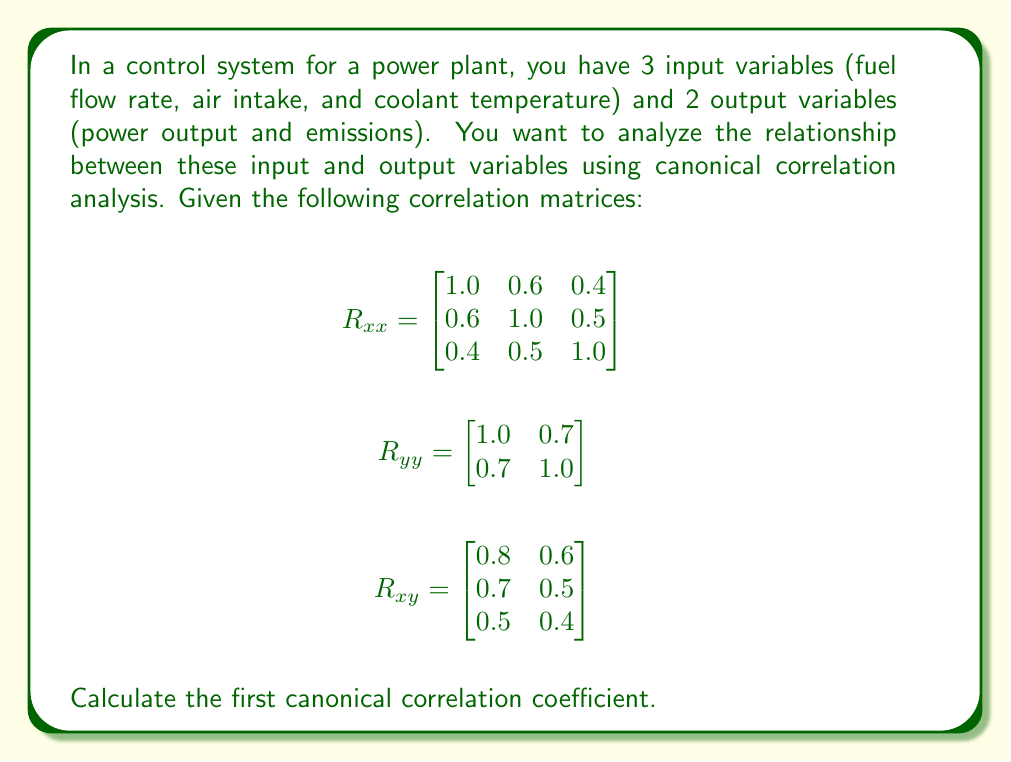Provide a solution to this math problem. To find the first canonical correlation coefficient, we need to follow these steps:

1. Calculate $R_{xx}^{-1}$ and $R_{yy}^{-1}$

First, let's calculate $R_{xx}^{-1}$:

$$R_{xx}^{-1} = \begin{bmatrix}
1.5625 & -0.9375 & -0.1875 \\
-0.9375 & 1.5625 & -0.4375 \\
-0.1875 & -0.4375 & 1.1875
\end{bmatrix}$$

Now, $R_{yy}^{-1}$:

$$R_{yy}^{-1} = \begin{bmatrix}
1.9608 & -1.3725 \\
-1.3725 & 1.9608
\end{bmatrix}$$

2. Calculate $R_{xx}^{-1}R_{xy}R_{yy}^{-1}R_{yx}$

$$R_{xx}^{-1}R_{xy}R_{yy}^{-1}R_{yx} = \begin{bmatrix}
0.7656 & -0.4688 & -0.0938 \\
-0.4688 & 0.5781 & -0.1406 \\
-0.0938 & -0.1406 & 0.2656
\end{bmatrix}$$

3. Find the eigenvalues of this matrix

The characteristic equation is:

$$(0.7656 - \lambda)(0.5781 - \lambda)(0.2656 - \lambda) + (-0.4688)(-0.1406)(-0.0938) + (-0.0938)(-0.4688)(-0.1406) - (0.7656 - \lambda)(-0.1406)^2 - (0.5781 - \lambda)(-0.0938)^2 - (0.2656 - \lambda)(-0.4688)^2 = 0$$

Solving this equation gives us the eigenvalues:

$\lambda_1 = 0.8164$, $\lambda_2 = 0.5625$, $\lambda_3 = 0.2304$

4. Take the square root of the largest eigenvalue

The first canonical correlation coefficient is the square root of the largest eigenvalue:

$$r_1 = \sqrt{\lambda_1} = \sqrt{0.8164} = 0.9035$$
Answer: The first canonical correlation coefficient is approximately 0.9035. 